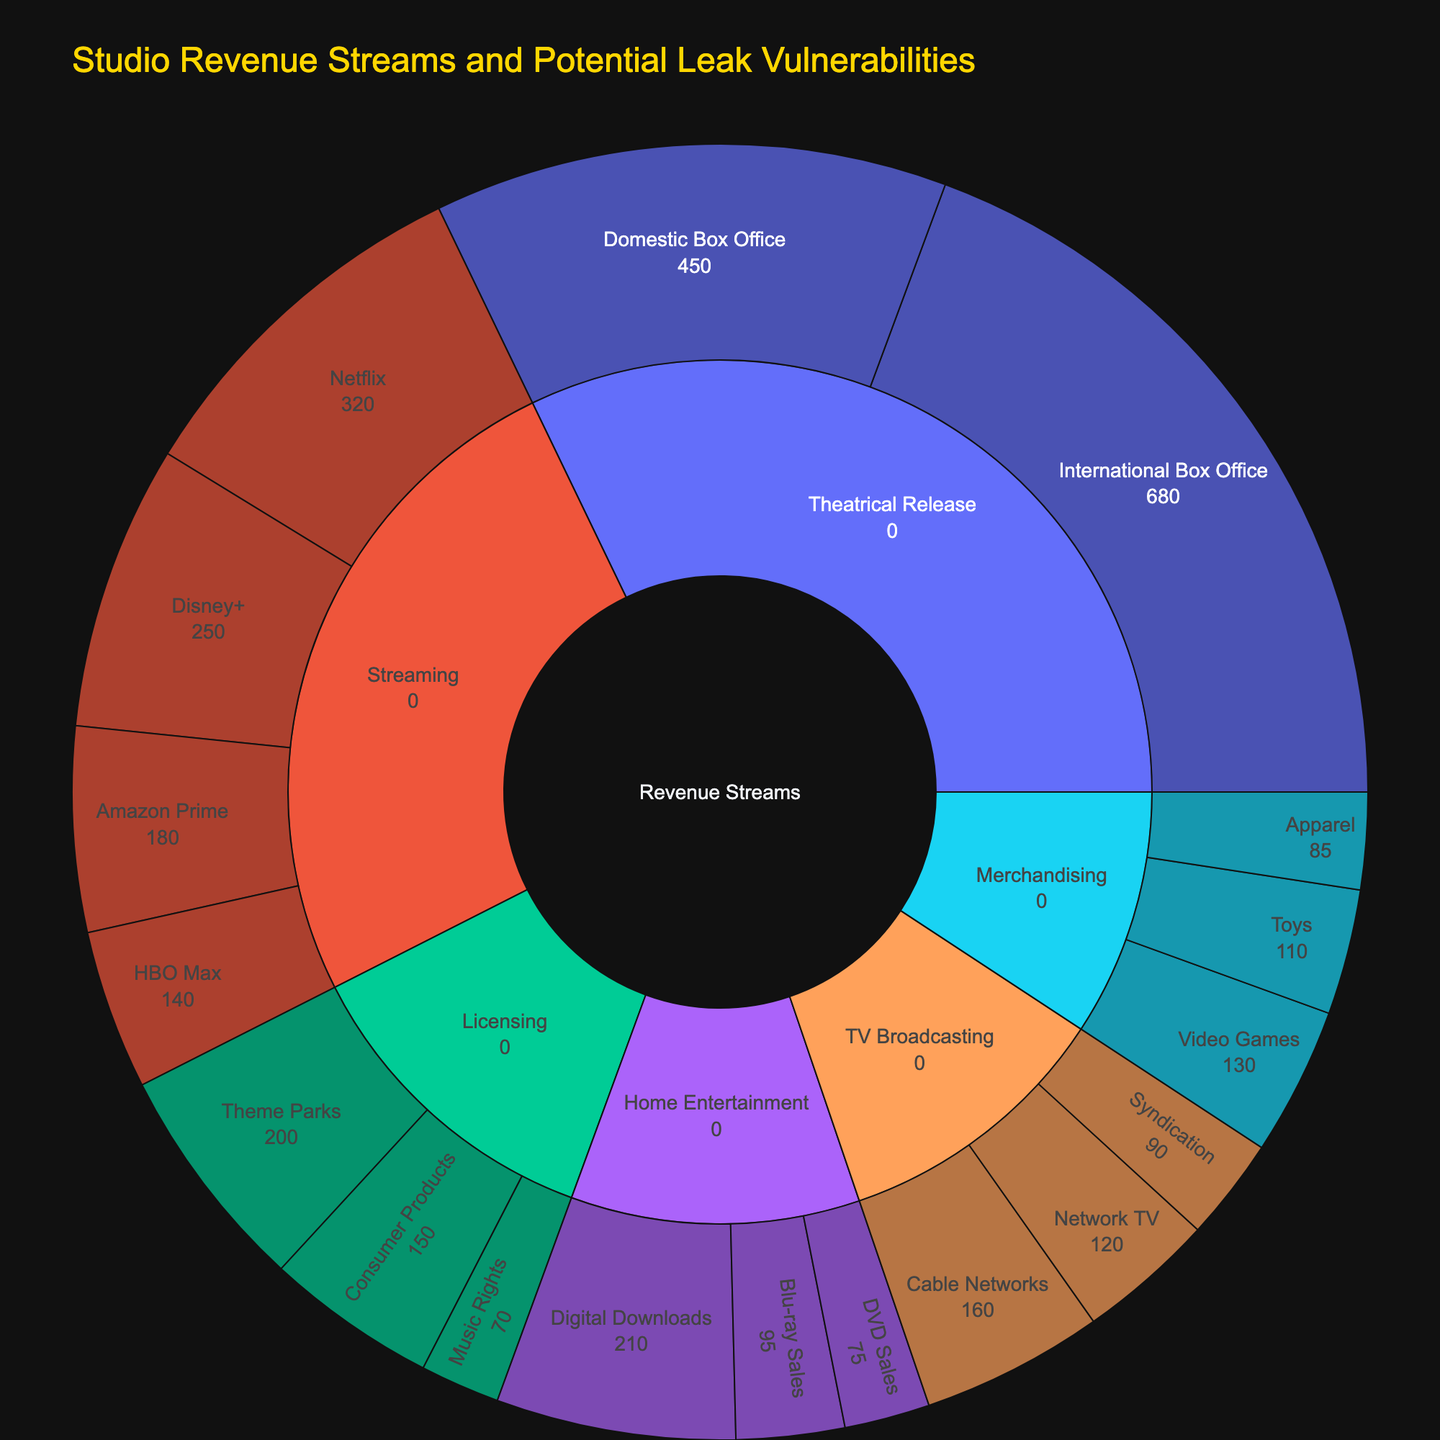How much revenue does Digital Downloads generate? Look at the Home Entertainment section and find the Digital Downloads segment to see its value.
Answer: $210M Which streaming service contributes the most revenue? In the Streaming section, compare the revenue values of Netflix, Amazon Prime, Disney+, and HBO Max. Disney+ has the highest value.
Answer: Disney+ What is the total revenue generated from Home Entertainment? Sum the values of Digital Downloads, Blu-ray Sales, and DVD Sales which are under the Home Entertainment section. So, 210 + 95 + 75 = 380
Answer: $380M How does the revenue from Theatrical Release compare to that from Streaming? Sum up Domestic Box Office and International Box Office for Theatrical Release (450 + 680), then sum up Netflix, Amazon Prime, Disney+, and HBO Max for Streaming (320 + 180 + 250 + 140). Compare 1130 to 890.
Answer: Theatrical Release generates more revenue Which category in TV Broadcasting generates the least revenue? In the TV Broadcasting section, compare the values of Cable Networks, Network TV, and Syndication. Syndication has the lowest value.
Answer: Syndication What's the difference in revenue between Toys and Apparel in Merchandising? Look at the Merchandising section and subtract the revenue of Apparel from the revenue of Toys (110 - 85).
Answer: $25M Which revenue stream contributes the least overall? Compare the sums of all sections: Theatrical Release, Home Entertainment, Streaming, TV Broadcasting, Merchandising, and Licensing. Find the section with the lowest total value. TV Broadcasting has the lowest total value.
Answer: TV Broadcasting Which Theatrical Release subcategory generates more revenue? Compare Domestic Box Office and International Box Office within the Theatrical Release section. International Box Office has a higher value.
Answer: International Box Office How much total revenue is generated from Licensing? Sum the values of Theme Parks, Consumer Products, and Music Rights under the Licensing section: 200 + 150 + 70 = 420.
Answer: $420M If we combine revenues from Digital Downloads and Network TV, what is the total? Add the revenue values from Digital Downloads (210) and Network TV (120). 210 + 120 = 330.
Answer: $330M 